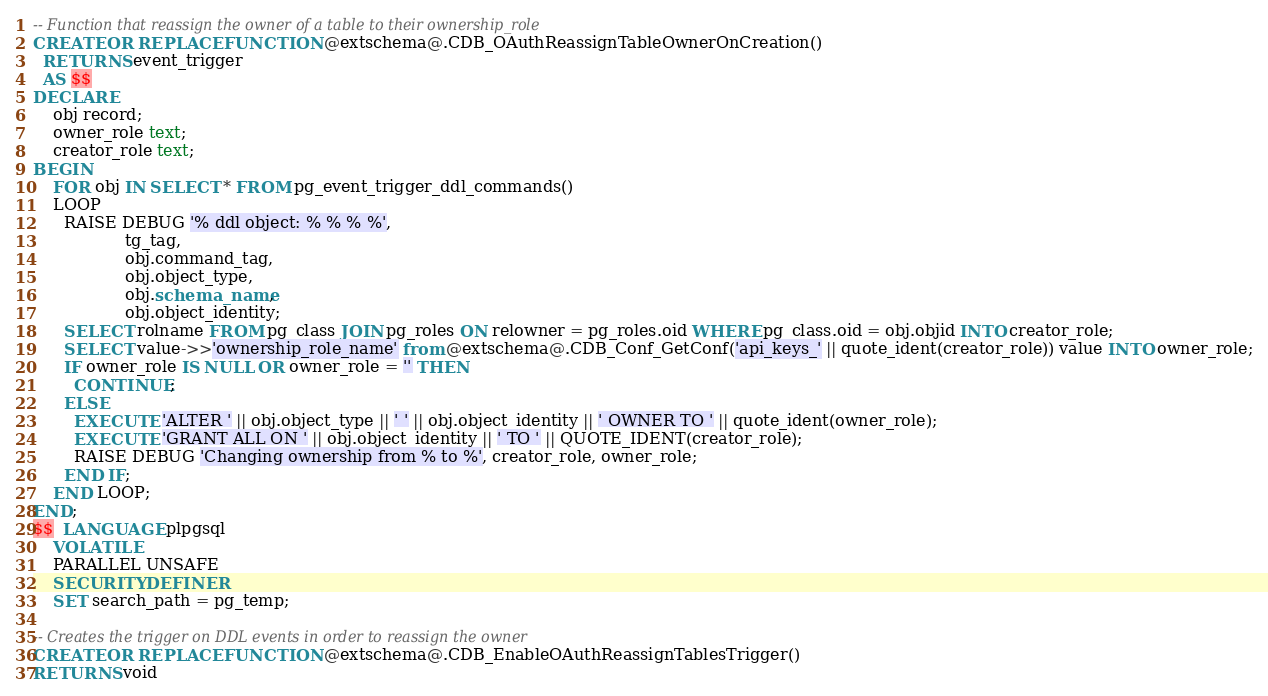<code> <loc_0><loc_0><loc_500><loc_500><_SQL_>-- Function that reassign the owner of a table to their ownership_role
CREATE OR REPLACE FUNCTION @extschema@.CDB_OAuthReassignTableOwnerOnCreation()
  RETURNS event_trigger
  AS $$
DECLARE
    obj record;
    owner_role text;
    creator_role text;
BEGIN
    FOR obj IN SELECT * FROM pg_event_trigger_ddl_commands()
    LOOP
      RAISE DEBUG '% ddl object: % % % %',
                  tg_tag,
                  obj.command_tag,
                  obj.object_type,
                  obj.schema_name,
                  obj.object_identity;
      SELECT rolname FROM pg_class JOIN pg_roles ON relowner = pg_roles.oid WHERE pg_class.oid = obj.objid INTO creator_role;
      SELECT value->>'ownership_role_name' from @extschema@.CDB_Conf_GetConf('api_keys_' || quote_ident(creator_role)) value INTO owner_role;
      IF owner_role IS NULL OR owner_role = '' THEN
        CONTINUE;
      ELSE
        EXECUTE 'ALTER ' || obj.object_type || ' ' || obj.object_identity || ' OWNER TO ' || quote_ident(owner_role);
        EXECUTE 'GRANT ALL ON ' || obj.object_identity || ' TO ' || QUOTE_IDENT(creator_role);
        RAISE DEBUG 'Changing ownership from % to %', creator_role, owner_role;
      END IF;
    END LOOP;
END;
$$  LANGUAGE plpgsql
    VOLATILE
    PARALLEL UNSAFE
    SECURITY DEFINER
    SET search_path = pg_temp;

-- Creates the trigger on DDL events in order to reassign the owner
CREATE OR REPLACE FUNCTION @extschema@.CDB_EnableOAuthReassignTablesTrigger()
RETURNS void</code> 